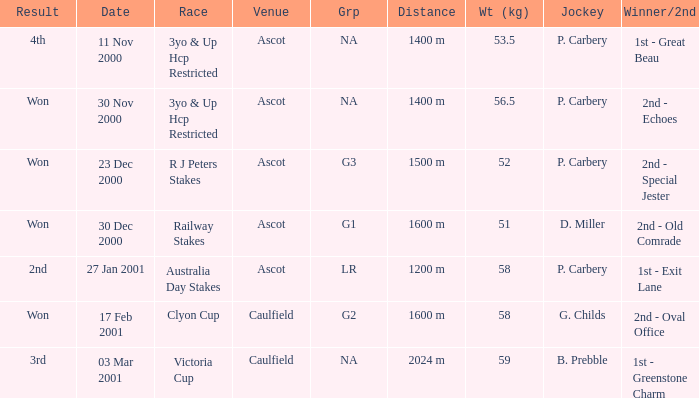I'm looking to parse the entire table for insights. Could you assist me with that? {'header': ['Result', 'Date', 'Race', 'Venue', 'Grp', 'Distance', 'Wt (kg)', 'Jockey', 'Winner/2nd'], 'rows': [['4th', '11 Nov 2000', '3yo & Up Hcp Restricted', 'Ascot', 'NA', '1400 m', '53.5', 'P. Carbery', '1st - Great Beau'], ['Won', '30 Nov 2000', '3yo & Up Hcp Restricted', 'Ascot', 'NA', '1400 m', '56.5', 'P. Carbery', '2nd - Echoes'], ['Won', '23 Dec 2000', 'R J Peters Stakes', 'Ascot', 'G3', '1500 m', '52', 'P. Carbery', '2nd - Special Jester'], ['Won', '30 Dec 2000', 'Railway Stakes', 'Ascot', 'G1', '1600 m', '51', 'D. Miller', '2nd - Old Comrade'], ['2nd', '27 Jan 2001', 'Australia Day Stakes', 'Ascot', 'LR', '1200 m', '58', 'P. Carbery', '1st - Exit Lane'], ['Won', '17 Feb 2001', 'Clyon Cup', 'Caulfield', 'G2', '1600 m', '58', 'G. Childs', '2nd - Oval Office'], ['3rd', '03 Mar 2001', 'Victoria Cup', 'Caulfield', 'NA', '2024 m', '59', 'B. Prebble', '1st - Greenstone Charm']]} What group info is available for the 56.5 kg weight? NA. 